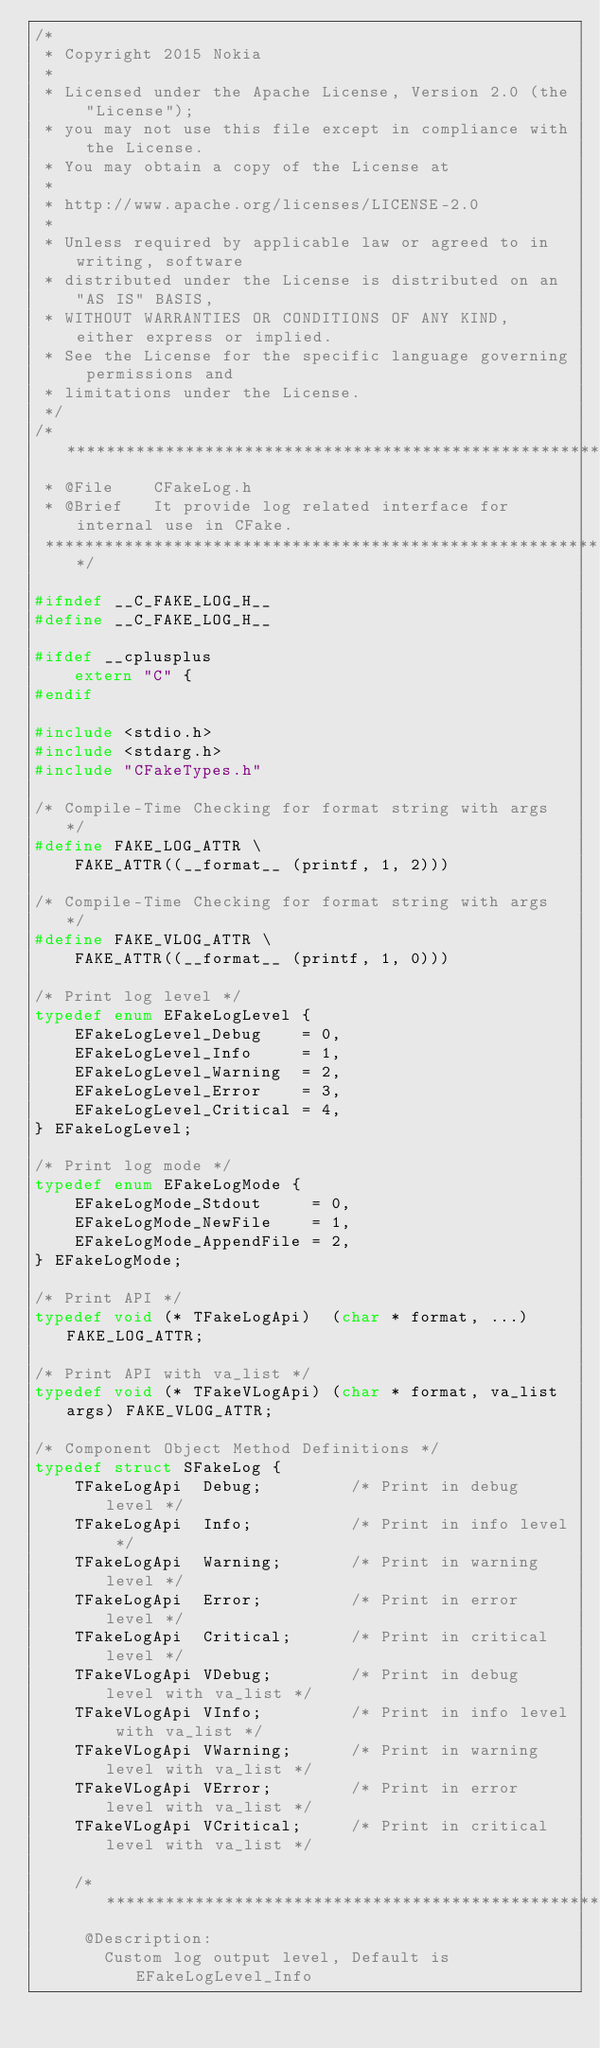<code> <loc_0><loc_0><loc_500><loc_500><_C_>/*
 * Copyright 2015 Nokia
 *
 * Licensed under the Apache License, Version 2.0 (the "License");
 * you may not use this file except in compliance with the License.
 * You may obtain a copy of the License at
 *
 * http://www.apache.org/licenses/LICENSE-2.0
 *
 * Unless required by applicable law or agreed to in writing, software
 * distributed under the License is distributed on an "AS IS" BASIS,
 * WITHOUT WARRANTIES OR CONDITIONS OF ANY KIND, either express or implied.
 * See the License for the specific language governing permissions and
 * limitations under the License.
 */
/******************************************************************************
 * @File    CFakeLog.h
 * @Brief   It provide log related interface for internal use in CFake.
 ******************************************************************************/

#ifndef __C_FAKE_LOG_H__
#define __C_FAKE_LOG_H__

#ifdef __cplusplus
    extern "C" {
#endif

#include <stdio.h>
#include <stdarg.h>
#include "CFakeTypes.h"

/* Compile-Time Checking for format string with args */
#define FAKE_LOG_ATTR \
    FAKE_ATTR((__format__ (printf, 1, 2)))

/* Compile-Time Checking for format string with args */
#define FAKE_VLOG_ATTR \
    FAKE_ATTR((__format__ (printf, 1, 0)))

/* Print log level */
typedef enum EFakeLogLevel {
    EFakeLogLevel_Debug    = 0,
    EFakeLogLevel_Info     = 1,
    EFakeLogLevel_Warning  = 2,
    EFakeLogLevel_Error    = 3,
    EFakeLogLevel_Critical = 4,
} EFakeLogLevel;

/* Print log mode */
typedef enum EFakeLogMode {
    EFakeLogMode_Stdout     = 0,
    EFakeLogMode_NewFile    = 1,
    EFakeLogMode_AppendFile = 2,
} EFakeLogMode;

/* Print API */
typedef void (* TFakeLogApi)  (char * format, ...) FAKE_LOG_ATTR;

/* Print API with va_list */
typedef void (* TFakeVLogApi) (char * format, va_list args) FAKE_VLOG_ATTR;

/* Component Object Method Definitions */
typedef struct SFakeLog {
    TFakeLogApi  Debug;         /* Print in debug level */
    TFakeLogApi  Info;          /* Print in info level */
    TFakeLogApi  Warning;       /* Print in warning level */
    TFakeLogApi  Error;         /* Print in error level */
    TFakeLogApi  Critical;      /* Print in critical level */
    TFakeVLogApi VDebug;        /* Print in debug level with va_list */
    TFakeVLogApi VInfo;         /* Print in info level with va_list */
    TFakeVLogApi VWarning;      /* Print in warning level with va_list */
    TFakeVLogApi VError;        /* Print in error level with va_list */
    TFakeVLogApi VCritical;     /* Print in critical level with va_list */

    /*****************************************************
     @Description:
       Custom log output level, Default is EFakeLogLevel_Info</code> 